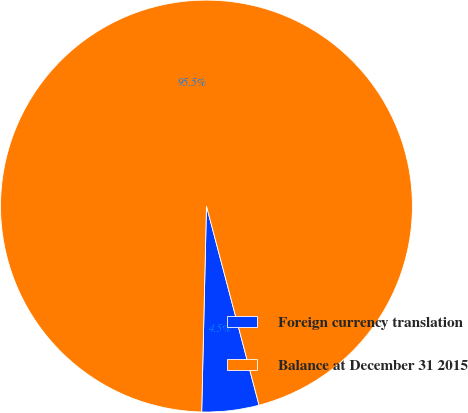Convert chart to OTSL. <chart><loc_0><loc_0><loc_500><loc_500><pie_chart><fcel>Foreign currency translation<fcel>Balance at December 31 2015<nl><fcel>4.48%<fcel>95.52%<nl></chart> 